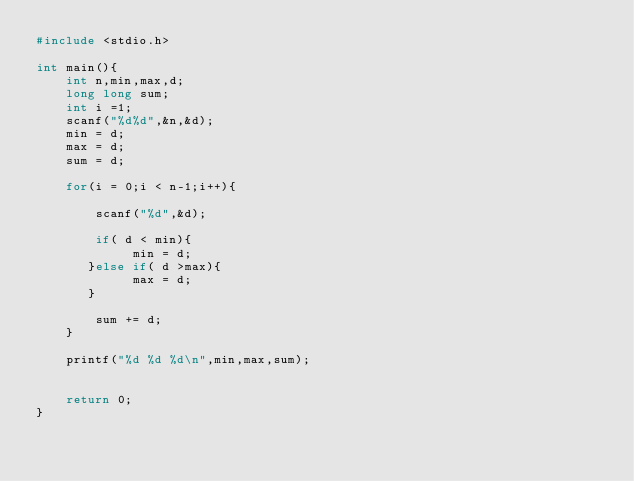<code> <loc_0><loc_0><loc_500><loc_500><_C_>#include <stdio.h>

int main(){
    int n,min,max,d;
    long long sum;
    int i =1;
    scanf("%d%d",&n,&d);
    min = d;
    max = d;
    sum = d;

    for(i = 0;i < n-1;i++){

        scanf("%d",&d);

        if( d < min){
             min = d;
       }else if( d >max){
             max = d;
       }

        sum += d;
    }

    printf("%d %d %d\n",min,max,sum);
 

    return 0;
}
</code> 